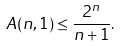<formula> <loc_0><loc_0><loc_500><loc_500>A ( n , 1 ) \leq \frac { 2 ^ { n } } { n + 1 } .</formula> 